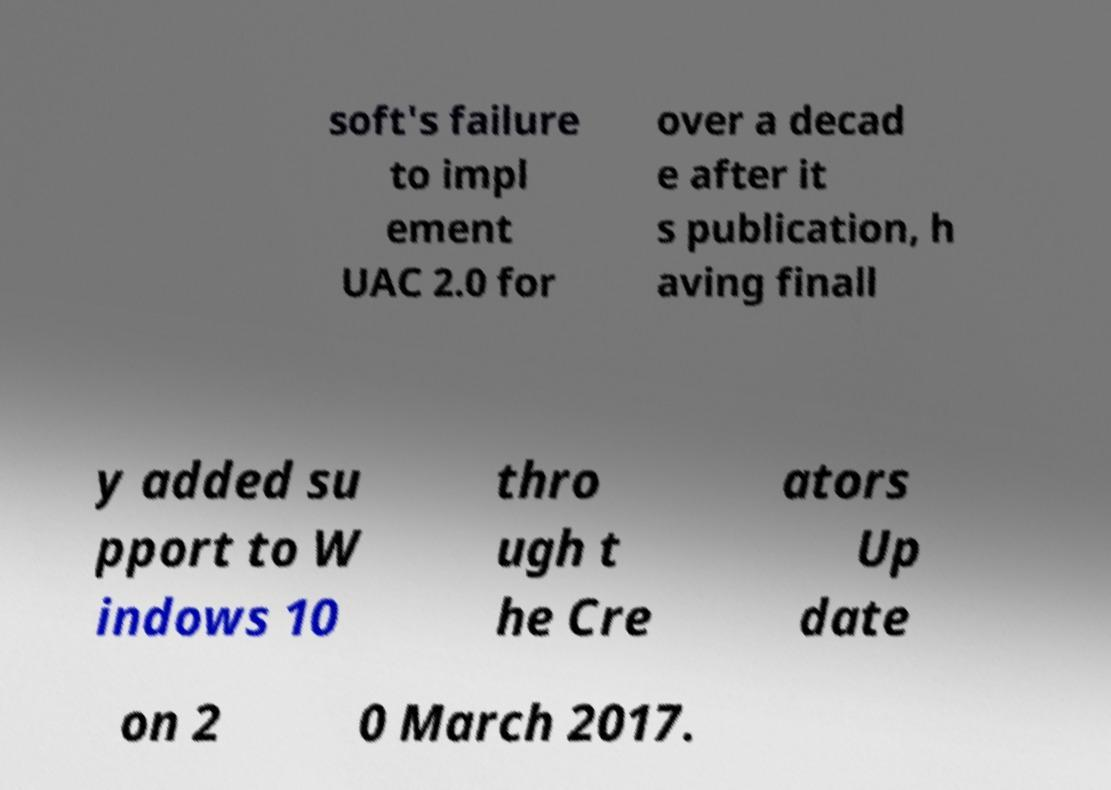Please identify and transcribe the text found in this image. soft's failure to impl ement UAC 2.0 for over a decad e after it s publication, h aving finall y added su pport to W indows 10 thro ugh t he Cre ators Up date on 2 0 March 2017. 